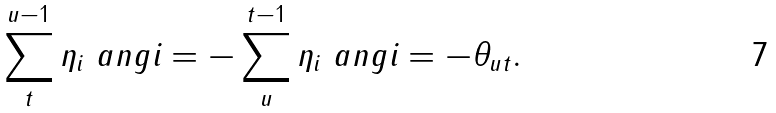Convert formula to latex. <formula><loc_0><loc_0><loc_500><loc_500>\sum _ { t } ^ { u - 1 } \eta _ { i } \ a n g { i } = - \sum _ { u } ^ { t - 1 } \eta _ { i } \ a n g { i } = - \theta _ { u t } .</formula> 